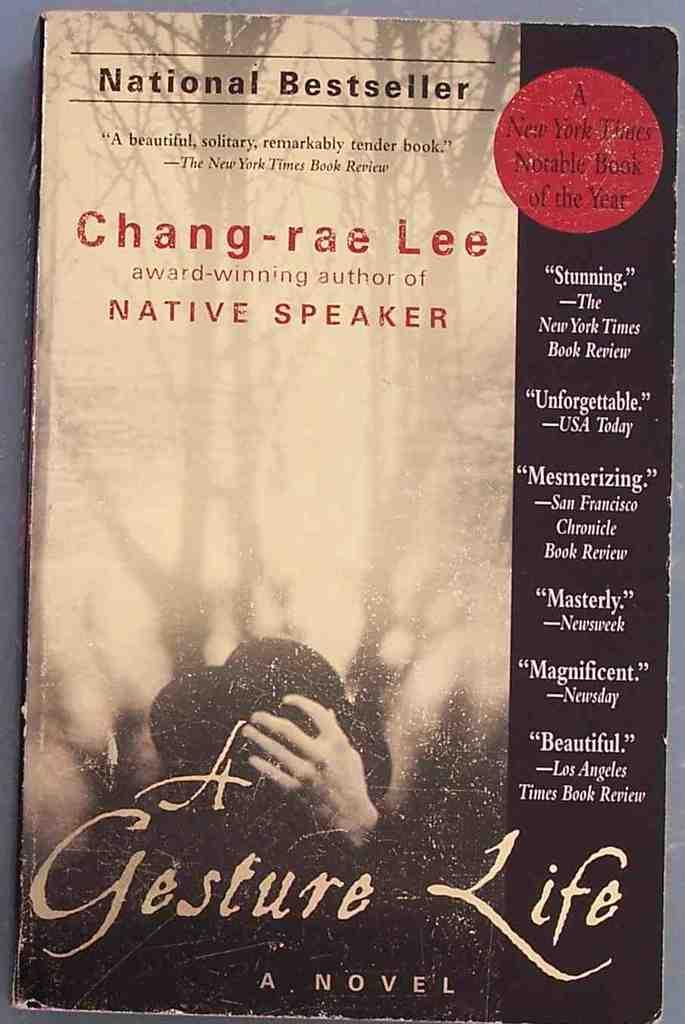Provide a one-sentence caption for the provided image. A book called A Gesture Life written by Chang-rae Lee. 